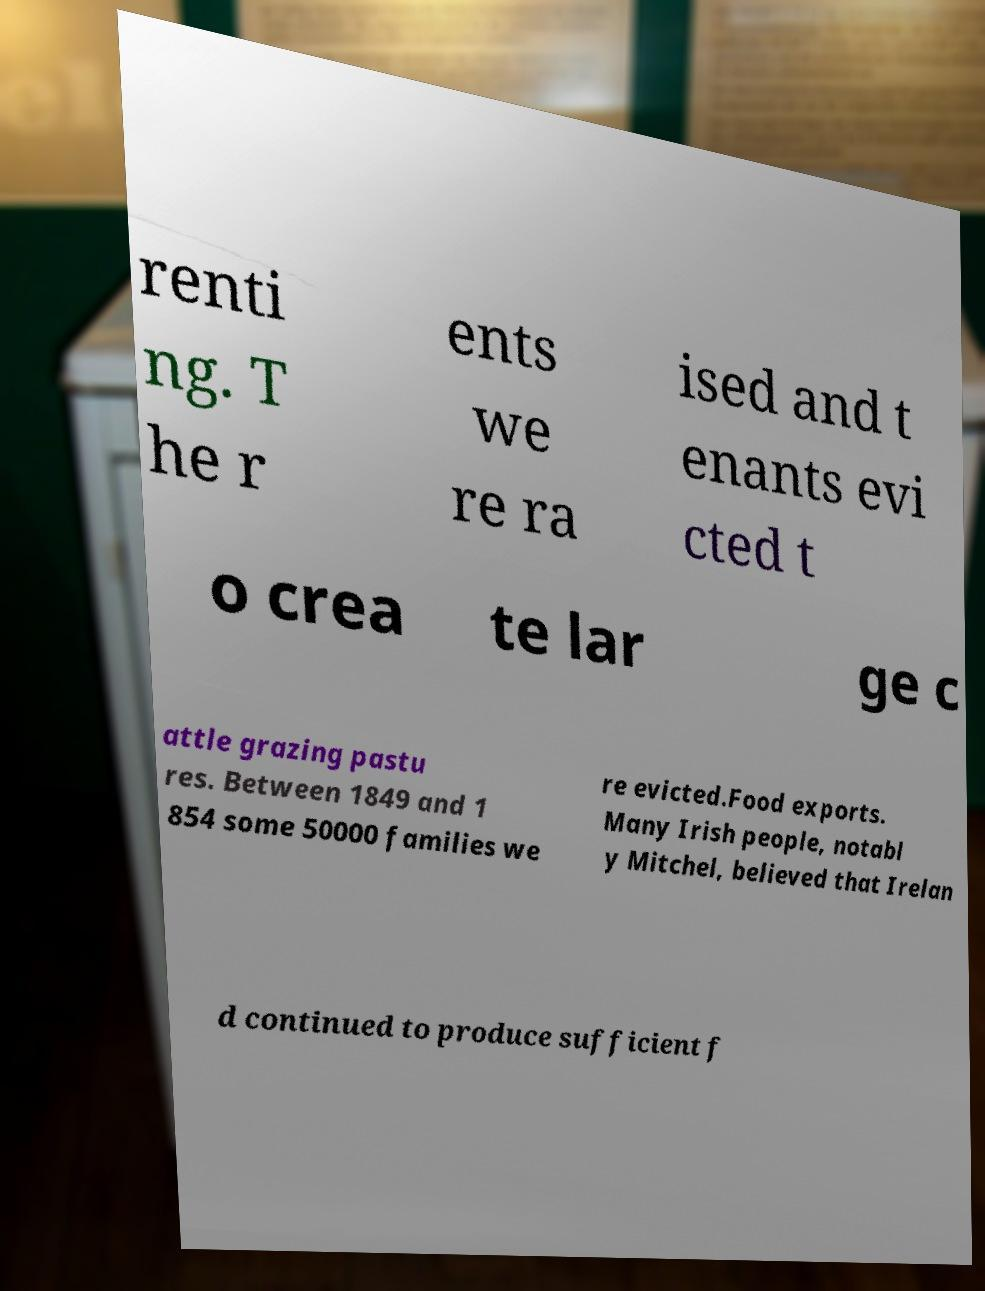Please read and relay the text visible in this image. What does it say? renti ng. T he r ents we re ra ised and t enants evi cted t o crea te lar ge c attle grazing pastu res. Between 1849 and 1 854 some 50000 families we re evicted.Food exports. Many Irish people, notabl y Mitchel, believed that Irelan d continued to produce sufficient f 